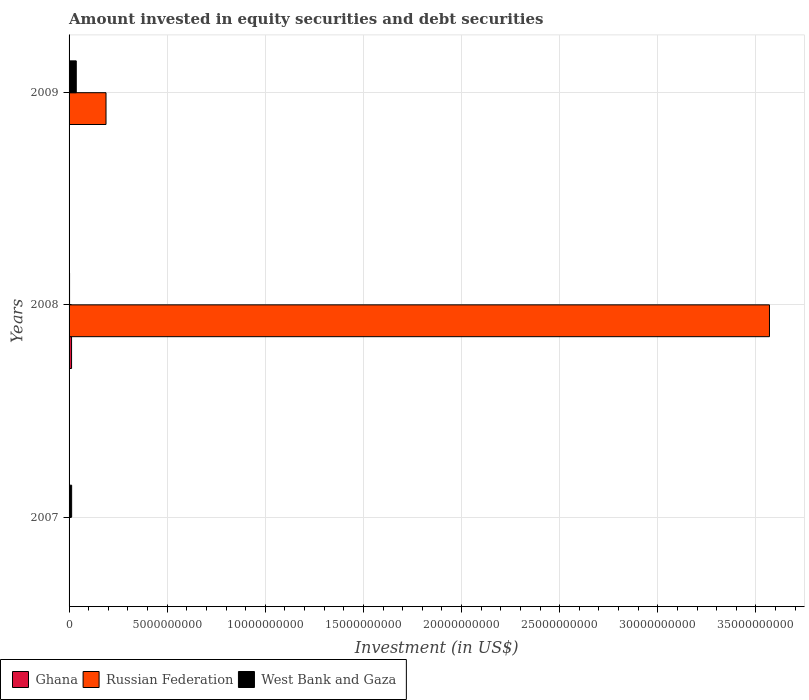How many different coloured bars are there?
Provide a short and direct response. 3. Are the number of bars on each tick of the Y-axis equal?
Provide a succinct answer. No. In how many cases, is the number of bars for a given year not equal to the number of legend labels?
Offer a terse response. 2. What is the amount invested in equity securities and debt securities in West Bank and Gaza in 2007?
Provide a short and direct response. 1.31e+08. Across all years, what is the maximum amount invested in equity securities and debt securities in Ghana?
Ensure brevity in your answer.  1.27e+08. Across all years, what is the minimum amount invested in equity securities and debt securities in Russian Federation?
Give a very brief answer. 0. What is the total amount invested in equity securities and debt securities in Ghana in the graph?
Keep it short and to the point. 1.27e+08. What is the difference between the amount invested in equity securities and debt securities in West Bank and Gaza in 2008 and that in 2009?
Provide a short and direct response. -3.42e+08. What is the difference between the amount invested in equity securities and debt securities in Ghana in 2009 and the amount invested in equity securities and debt securities in Russian Federation in 2008?
Make the answer very short. -3.57e+1. What is the average amount invested in equity securities and debt securities in West Bank and Gaza per year?
Ensure brevity in your answer.  1.74e+08. In the year 2008, what is the difference between the amount invested in equity securities and debt securities in West Bank and Gaza and amount invested in equity securities and debt securities in Russian Federation?
Offer a very short reply. -3.57e+1. What is the ratio of the amount invested in equity securities and debt securities in West Bank and Gaza in 2007 to that in 2008?
Your response must be concise. 5.3. Is the difference between the amount invested in equity securities and debt securities in West Bank and Gaza in 2008 and 2009 greater than the difference between the amount invested in equity securities and debt securities in Russian Federation in 2008 and 2009?
Your response must be concise. No. What is the difference between the highest and the second highest amount invested in equity securities and debt securities in West Bank and Gaza?
Give a very brief answer. 2.36e+08. What is the difference between the highest and the lowest amount invested in equity securities and debt securities in Russian Federation?
Offer a very short reply. 3.57e+1. In how many years, is the amount invested in equity securities and debt securities in West Bank and Gaza greater than the average amount invested in equity securities and debt securities in West Bank and Gaza taken over all years?
Your answer should be very brief. 1. What is the difference between two consecutive major ticks on the X-axis?
Provide a succinct answer. 5.00e+09. Are the values on the major ticks of X-axis written in scientific E-notation?
Provide a short and direct response. No. Does the graph contain grids?
Give a very brief answer. Yes. Where does the legend appear in the graph?
Your answer should be very brief. Bottom left. How many legend labels are there?
Make the answer very short. 3. What is the title of the graph?
Your answer should be very brief. Amount invested in equity securities and debt securities. Does "Dominican Republic" appear as one of the legend labels in the graph?
Your answer should be very brief. No. What is the label or title of the X-axis?
Offer a terse response. Investment (in US$). What is the label or title of the Y-axis?
Offer a terse response. Years. What is the Investment (in US$) in West Bank and Gaza in 2007?
Your response must be concise. 1.31e+08. What is the Investment (in US$) in Ghana in 2008?
Your response must be concise. 1.27e+08. What is the Investment (in US$) of Russian Federation in 2008?
Your response must be concise. 3.57e+1. What is the Investment (in US$) in West Bank and Gaza in 2008?
Your answer should be compact. 2.47e+07. What is the Investment (in US$) in Ghana in 2009?
Make the answer very short. 0. What is the Investment (in US$) of Russian Federation in 2009?
Offer a terse response. 1.88e+09. What is the Investment (in US$) in West Bank and Gaza in 2009?
Your response must be concise. 3.67e+08. Across all years, what is the maximum Investment (in US$) of Ghana?
Provide a short and direct response. 1.27e+08. Across all years, what is the maximum Investment (in US$) of Russian Federation?
Ensure brevity in your answer.  3.57e+1. Across all years, what is the maximum Investment (in US$) of West Bank and Gaza?
Your answer should be compact. 3.67e+08. Across all years, what is the minimum Investment (in US$) in Ghana?
Offer a very short reply. 0. Across all years, what is the minimum Investment (in US$) of West Bank and Gaza?
Keep it short and to the point. 2.47e+07. What is the total Investment (in US$) of Ghana in the graph?
Ensure brevity in your answer.  1.27e+08. What is the total Investment (in US$) of Russian Federation in the graph?
Ensure brevity in your answer.  3.76e+1. What is the total Investment (in US$) in West Bank and Gaza in the graph?
Give a very brief answer. 5.22e+08. What is the difference between the Investment (in US$) of West Bank and Gaza in 2007 and that in 2008?
Your answer should be compact. 1.06e+08. What is the difference between the Investment (in US$) in West Bank and Gaza in 2007 and that in 2009?
Your answer should be compact. -2.36e+08. What is the difference between the Investment (in US$) of Russian Federation in 2008 and that in 2009?
Make the answer very short. 3.38e+1. What is the difference between the Investment (in US$) of West Bank and Gaza in 2008 and that in 2009?
Provide a succinct answer. -3.42e+08. What is the difference between the Investment (in US$) of Ghana in 2008 and the Investment (in US$) of Russian Federation in 2009?
Your answer should be very brief. -1.76e+09. What is the difference between the Investment (in US$) in Ghana in 2008 and the Investment (in US$) in West Bank and Gaza in 2009?
Give a very brief answer. -2.39e+08. What is the difference between the Investment (in US$) of Russian Federation in 2008 and the Investment (in US$) of West Bank and Gaza in 2009?
Provide a succinct answer. 3.53e+1. What is the average Investment (in US$) in Ghana per year?
Give a very brief answer. 4.24e+07. What is the average Investment (in US$) in Russian Federation per year?
Make the answer very short. 1.25e+1. What is the average Investment (in US$) of West Bank and Gaza per year?
Ensure brevity in your answer.  1.74e+08. In the year 2008, what is the difference between the Investment (in US$) of Ghana and Investment (in US$) of Russian Federation?
Your answer should be compact. -3.56e+1. In the year 2008, what is the difference between the Investment (in US$) of Ghana and Investment (in US$) of West Bank and Gaza?
Your response must be concise. 1.03e+08. In the year 2008, what is the difference between the Investment (in US$) in Russian Federation and Investment (in US$) in West Bank and Gaza?
Give a very brief answer. 3.57e+1. In the year 2009, what is the difference between the Investment (in US$) of Russian Federation and Investment (in US$) of West Bank and Gaza?
Make the answer very short. 1.52e+09. What is the ratio of the Investment (in US$) of West Bank and Gaza in 2007 to that in 2008?
Offer a terse response. 5.3. What is the ratio of the Investment (in US$) of West Bank and Gaza in 2007 to that in 2009?
Your response must be concise. 0.36. What is the ratio of the Investment (in US$) of Russian Federation in 2008 to that in 2009?
Provide a short and direct response. 18.96. What is the ratio of the Investment (in US$) of West Bank and Gaza in 2008 to that in 2009?
Provide a short and direct response. 0.07. What is the difference between the highest and the second highest Investment (in US$) in West Bank and Gaza?
Ensure brevity in your answer.  2.36e+08. What is the difference between the highest and the lowest Investment (in US$) of Ghana?
Keep it short and to the point. 1.27e+08. What is the difference between the highest and the lowest Investment (in US$) in Russian Federation?
Make the answer very short. 3.57e+1. What is the difference between the highest and the lowest Investment (in US$) of West Bank and Gaza?
Ensure brevity in your answer.  3.42e+08. 